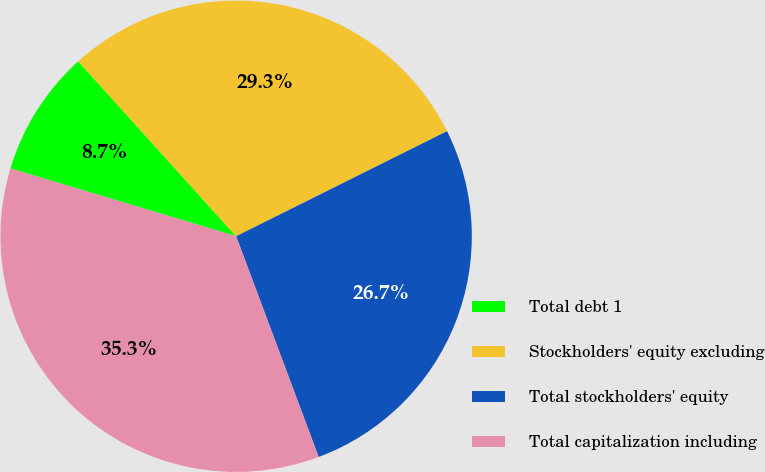Convert chart to OTSL. <chart><loc_0><loc_0><loc_500><loc_500><pie_chart><fcel>Total debt 1<fcel>Stockholders' equity excluding<fcel>Total stockholders' equity<fcel>Total capitalization including<nl><fcel>8.67%<fcel>29.33%<fcel>26.66%<fcel>35.34%<nl></chart> 